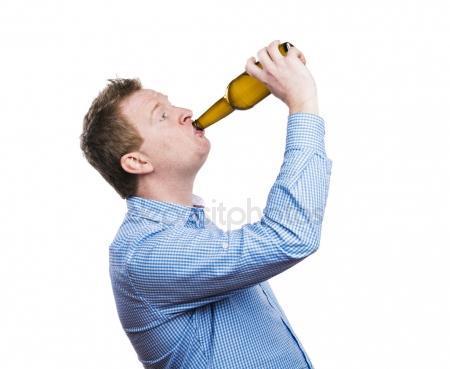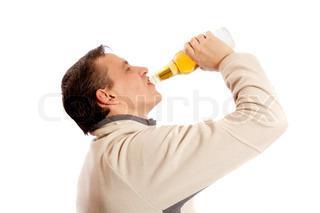The first image is the image on the left, the second image is the image on the right. Assess this claim about the two images: "There are exactly two bottles.". Correct or not? Answer yes or no. Yes. The first image is the image on the left, the second image is the image on the right. Analyze the images presented: Is the assertion "The men in both images are drinking beer, touching the bottle to their lips." valid? Answer yes or no. Yes. 